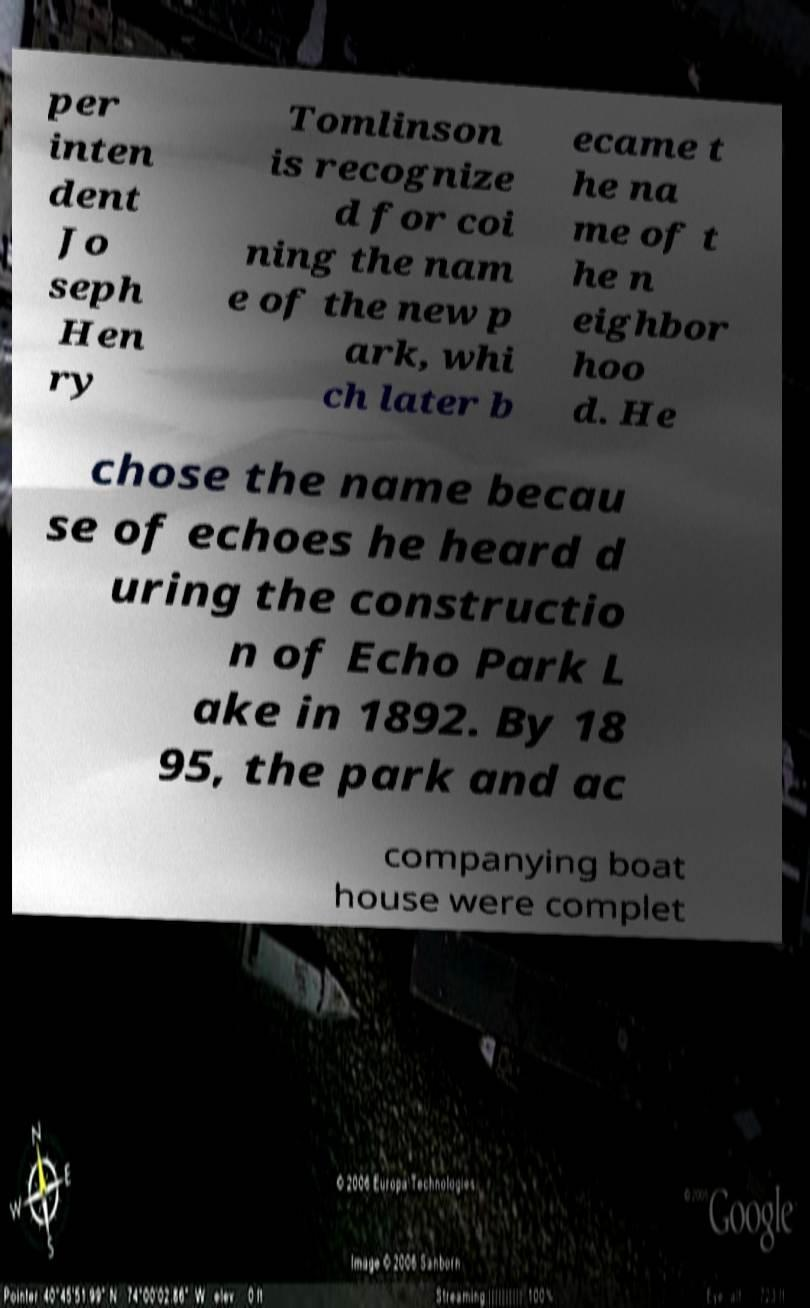For documentation purposes, I need the text within this image transcribed. Could you provide that? per inten dent Jo seph Hen ry Tomlinson is recognize d for coi ning the nam e of the new p ark, whi ch later b ecame t he na me of t he n eighbor hoo d. He chose the name becau se of echoes he heard d uring the constructio n of Echo Park L ake in 1892. By 18 95, the park and ac companying boat house were complet 